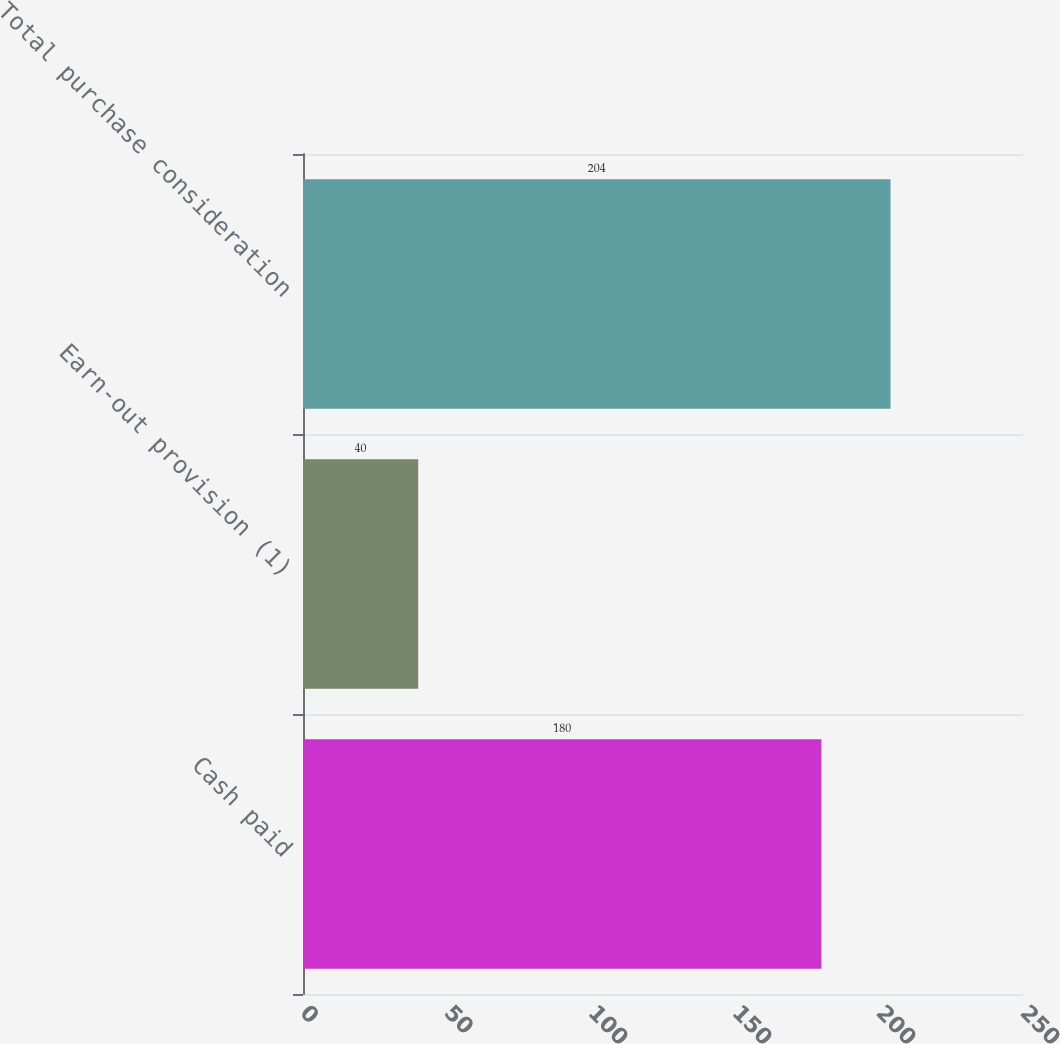Convert chart. <chart><loc_0><loc_0><loc_500><loc_500><bar_chart><fcel>Cash paid<fcel>Earn-out provision (1)<fcel>Total purchase consideration<nl><fcel>180<fcel>40<fcel>204<nl></chart> 